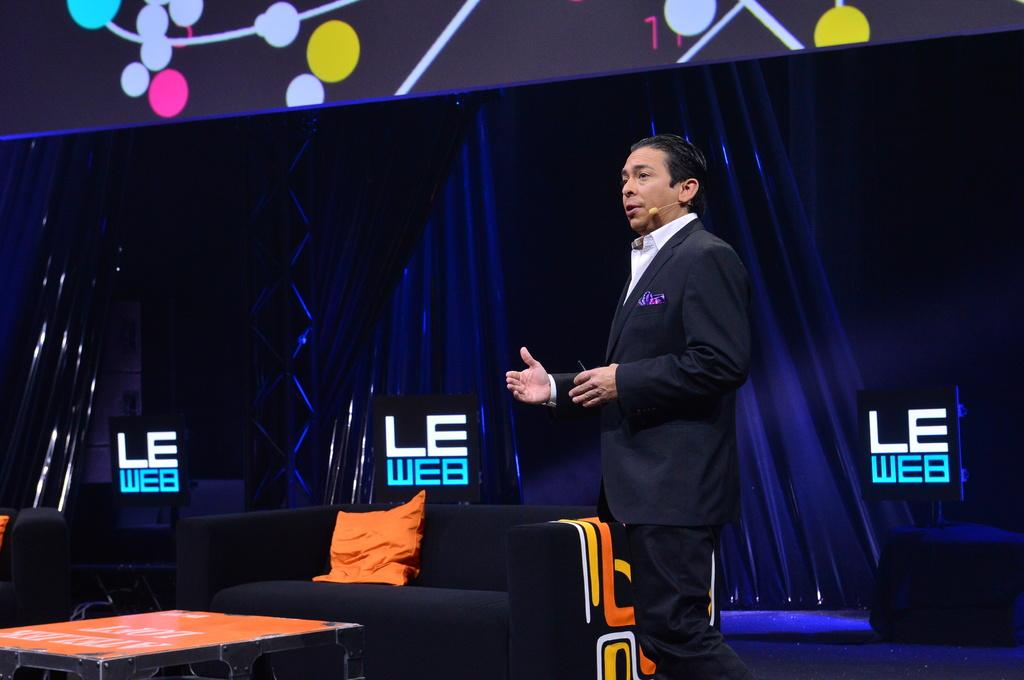What color is the word "web" on the monitors?
Offer a very short reply. Blue. 